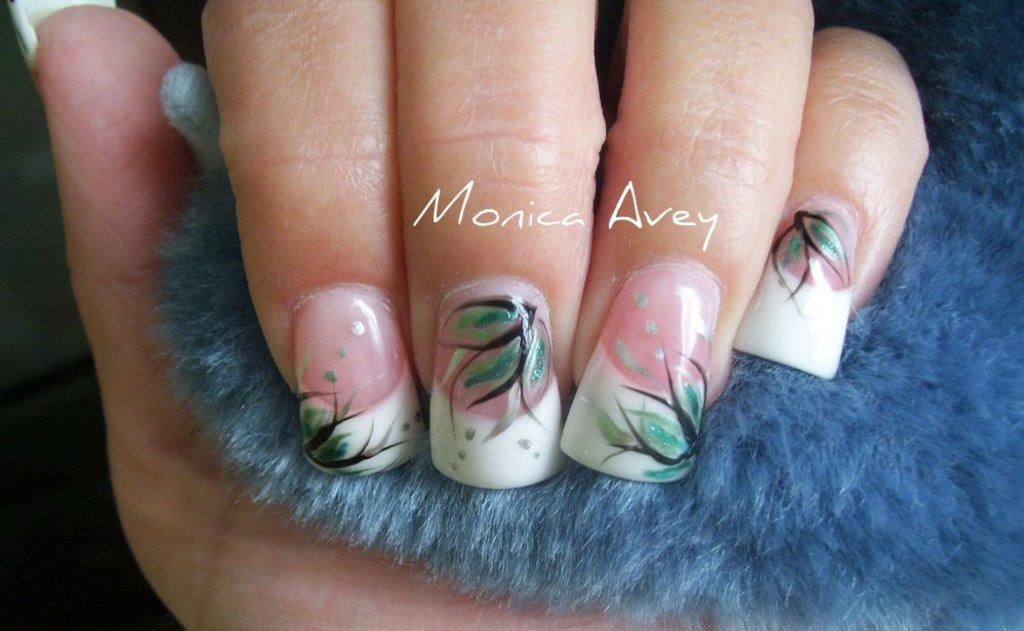What is the color of the object being held in the image? The object being held in the image is blue. What can be seen on the person's nails in the image? Nail polish is visible on the nails in the image. How would you describe the background of the image? The background of the image is dark. What type of scarecrow is standing in the background of the image? There is no scarecrow present in the image. How does the yak feel about the blue object being held in the image? There is no yak present in the image, so it is not possible to determine its feelings about the blue object. 